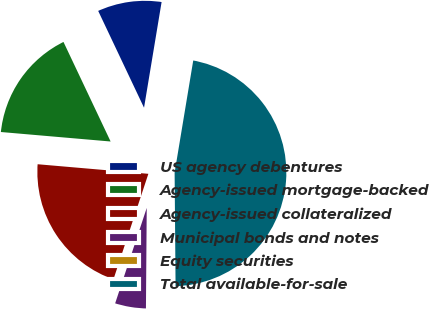Convert chart. <chart><loc_0><loc_0><loc_500><loc_500><pie_chart><fcel>US agency debentures<fcel>Agency-issued mortgage-backed<fcel>Agency-issued collateralized<fcel>Municipal bonds and notes<fcel>Equity securities<fcel>Total available-for-sale<nl><fcel>9.66%<fcel>16.59%<fcel>21.29%<fcel>4.96%<fcel>0.26%<fcel>47.25%<nl></chart> 